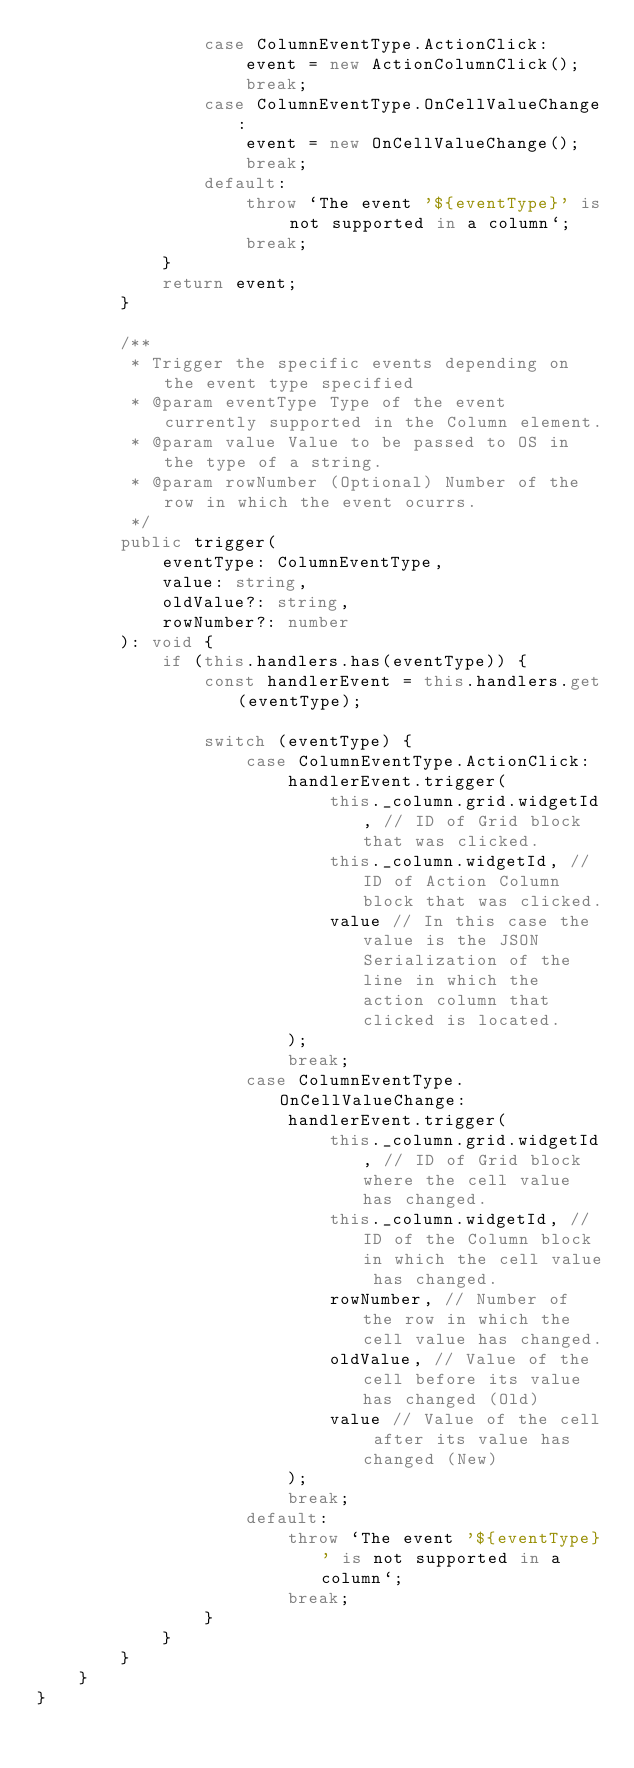<code> <loc_0><loc_0><loc_500><loc_500><_TypeScript_>                case ColumnEventType.ActionClick:
                    event = new ActionColumnClick();
                    break;
                case ColumnEventType.OnCellValueChange:
                    event = new OnCellValueChange();
                    break;
                default:
                    throw `The event '${eventType}' is not supported in a column`;
                    break;
            }
            return event;
        }

        /**
         * Trigger the specific events depending on the event type specified
         * @param eventType Type of the event currently supported in the Column element.
         * @param value Value to be passed to OS in the type of a string.
         * @param rowNumber (Optional) Number of the row in which the event ocurrs.
         */
        public trigger(
            eventType: ColumnEventType,
            value: string,
            oldValue?: string,
            rowNumber?: number
        ): void {
            if (this.handlers.has(eventType)) {
                const handlerEvent = this.handlers.get(eventType);

                switch (eventType) {
                    case ColumnEventType.ActionClick:
                        handlerEvent.trigger(
                            this._column.grid.widgetId, // ID of Grid block that was clicked.
                            this._column.widgetId, // ID of Action Column block that was clicked.
                            value // In this case the value is the JSON Serialization of the line in which the action column that clicked is located.
                        );
                        break;
                    case ColumnEventType.OnCellValueChange:
                        handlerEvent.trigger(
                            this._column.grid.widgetId, // ID of Grid block where the cell value has changed.
                            this._column.widgetId, // ID of the Column block in which the cell value has changed.
                            rowNumber, // Number of the row in which the cell value has changed.
                            oldValue, // Value of the cell before its value has changed (Old)
                            value // Value of the cell after its value has changed (New)
                        );
                        break;
                    default:
                        throw `The event '${eventType}' is not supported in a column`;
                        break;
                }
            }
        }
    }
}
</code> 